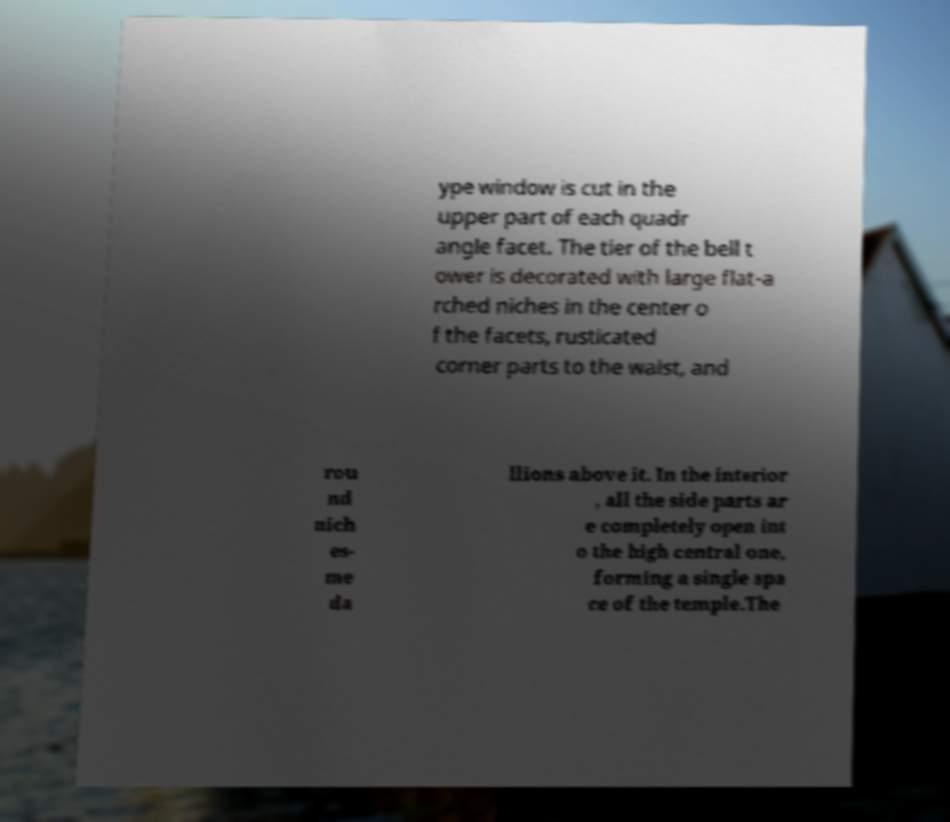Could you extract and type out the text from this image? ype window is cut in the upper part of each quadr angle facet. The tier of the bell t ower is decorated with large flat-a rched niches in the center o f the facets, rusticated corner parts to the waist, and rou nd nich es- me da llions above it. In the interior , all the side parts ar e completely open int o the high central one, forming a single spa ce of the temple.The 